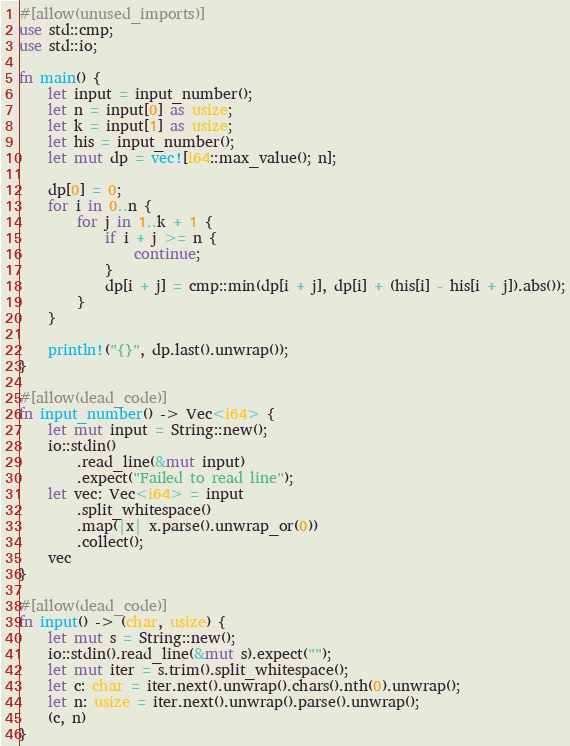<code> <loc_0><loc_0><loc_500><loc_500><_Rust_>#[allow(unused_imports)]
use std::cmp;
use std::io;

fn main() {
    let input = input_number();
    let n = input[0] as usize;
    let k = input[1] as usize;
    let his = input_number();
    let mut dp = vec![i64::max_value(); n];

    dp[0] = 0;
    for i in 0..n {
        for j in 1..k + 1 {
            if i + j >= n {
                continue;
            }
            dp[i + j] = cmp::min(dp[i + j], dp[i] + (his[i] - his[i + j]).abs());
        }
    }

    println!("{}", dp.last().unwrap());
}

#[allow(dead_code)]
fn input_number() -> Vec<i64> {
    let mut input = String::new();
    io::stdin()
        .read_line(&mut input)
        .expect("Failed to read line");
    let vec: Vec<i64> = input
        .split_whitespace()
        .map(|x| x.parse().unwrap_or(0))
        .collect();
    vec
}

#[allow(dead_code)]
fn input() -> (char, usize) {
    let mut s = String::new();
    io::stdin().read_line(&mut s).expect("");
    let mut iter = s.trim().split_whitespace();
    let c: char = iter.next().unwrap().chars().nth(0).unwrap();
    let n: usize = iter.next().unwrap().parse().unwrap();
    (c, n)
}
</code> 